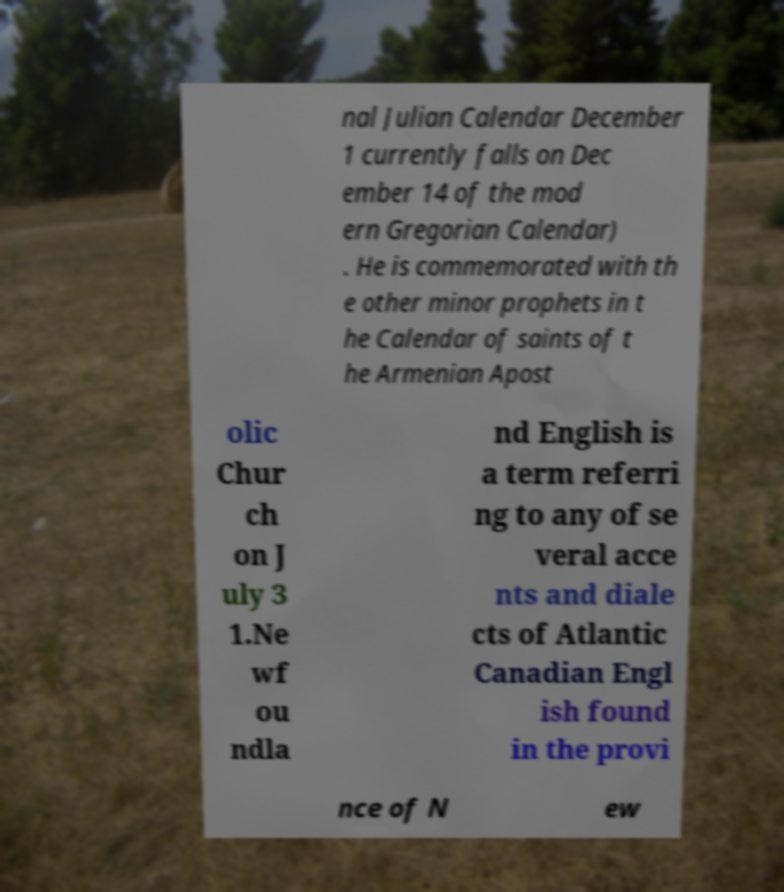I need the written content from this picture converted into text. Can you do that? nal Julian Calendar December 1 currently falls on Dec ember 14 of the mod ern Gregorian Calendar) . He is commemorated with th e other minor prophets in t he Calendar of saints of t he Armenian Apost olic Chur ch on J uly 3 1.Ne wf ou ndla nd English is a term referri ng to any of se veral acce nts and diale cts of Atlantic Canadian Engl ish found in the provi nce of N ew 